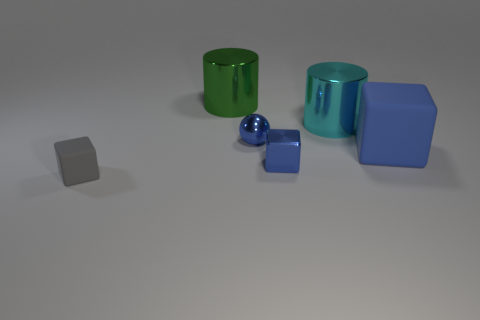Subtract all blue blocks. How many were subtracted if there are1blue blocks left? 1 Add 2 blocks. How many objects exist? 8 Subtract all spheres. How many objects are left? 5 Add 1 large cyan metal cylinders. How many large cyan metal cylinders are left? 2 Add 2 big blue objects. How many big blue objects exist? 3 Subtract 0 blue cylinders. How many objects are left? 6 Subtract all objects. Subtract all big cyan balls. How many objects are left? 0 